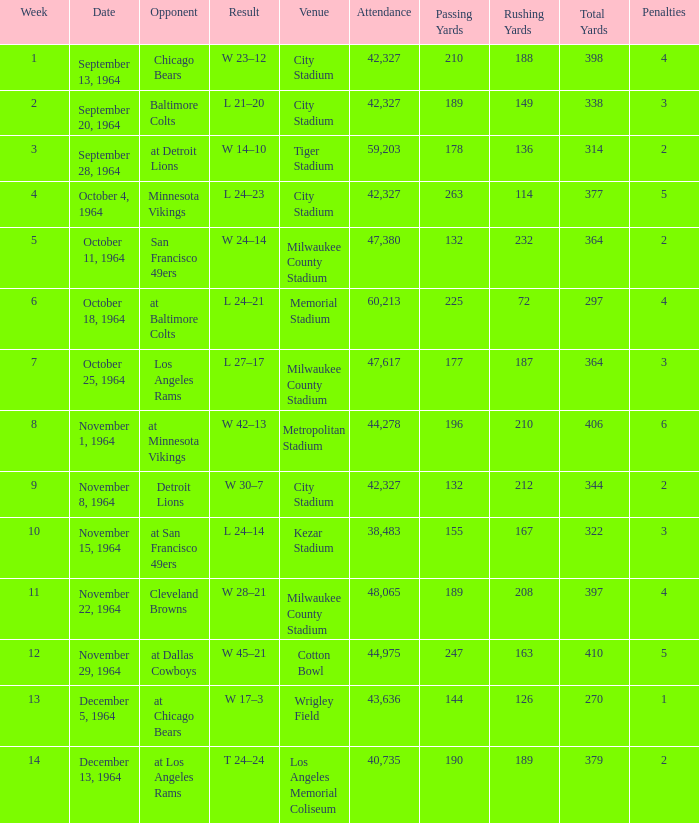What is the average week of the game on November 22, 1964 attended by 48,065? None. 